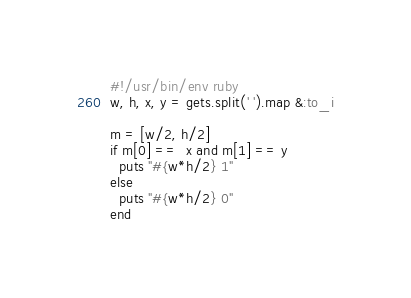<code> <loc_0><loc_0><loc_500><loc_500><_Ruby_>#!/usr/bin/env ruby
w, h, x, y = gets.split(' ').map &:to_i

m = [w/2, h/2]
if m[0] ==  x and m[1] == y
  puts "#{w*h/2} 1"
else
  puts "#{w*h/2} 0"
end
</code> 